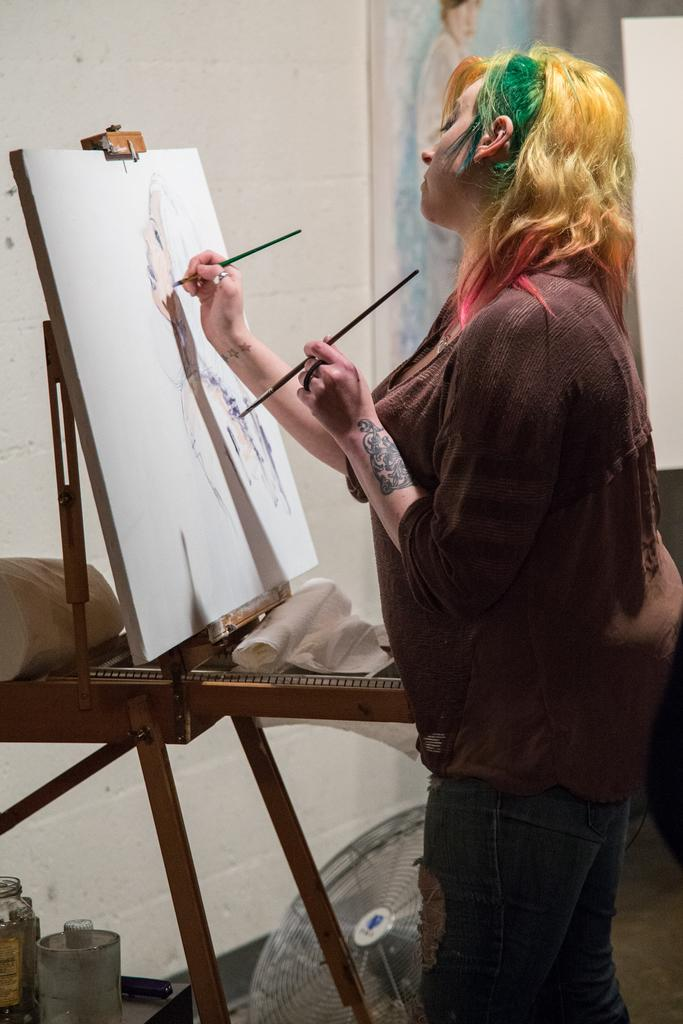What is the woman in the image doing? There is a woman painting in the image. What objects are present in the image besides the woman? There are chats, a board, bottles, and a fan visible in the image. What can be seen in the background of the image? There are boards and a wall in the background of the image. What type of flowers can be seen growing near the gate in the image? There is no gate or flowers present in the image. What type of brush is the woman using to paint in the image? The image does not show the specific type of brush the woman is using to paint. 